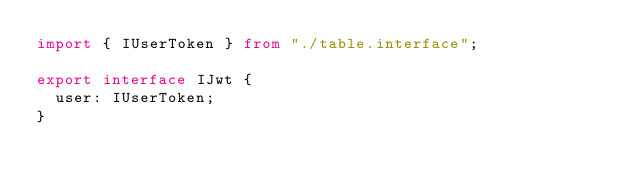Convert code to text. <code><loc_0><loc_0><loc_500><loc_500><_TypeScript_>import { IUserToken } from "./table.interface";

export interface IJwt {
  user: IUserToken;
}
</code> 